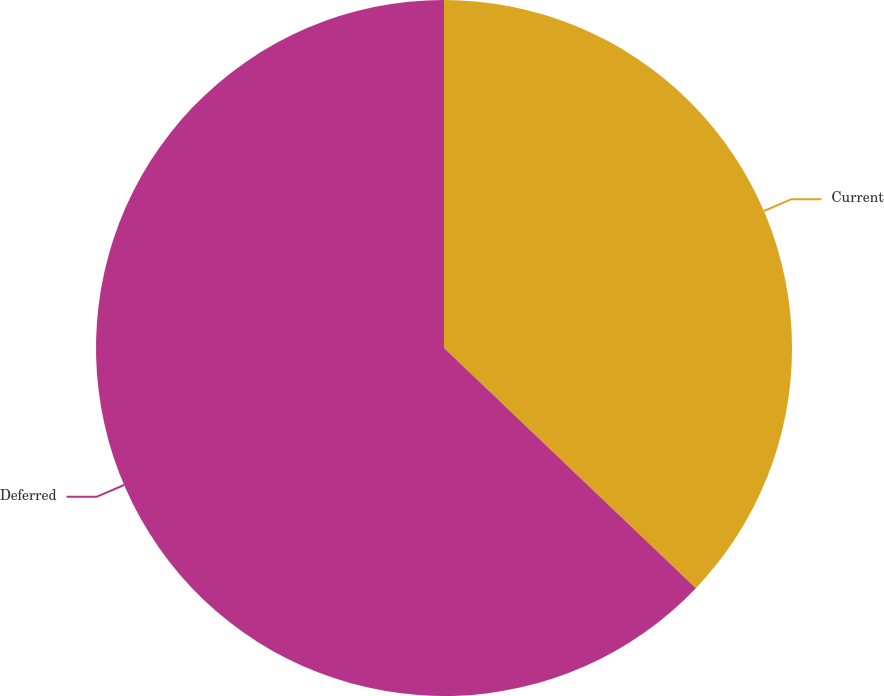Convert chart to OTSL. <chart><loc_0><loc_0><loc_500><loc_500><pie_chart><fcel>Current<fcel>Deferred<nl><fcel>37.12%<fcel>62.88%<nl></chart> 